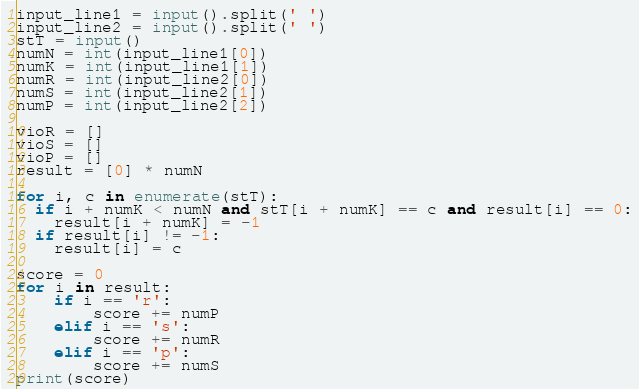Convert code to text. <code><loc_0><loc_0><loc_500><loc_500><_Python_>input_line1 = input().split(' ')
input_line2 = input().split(' ')
stT = input()
numN = int(input_line1[0])
numK = int(input_line1[1])
numR = int(input_line2[0])
numS = int(input_line2[1])
numP = int(input_line2[2])

vioR = []
vioS = []
vioP = []
result = [0] * numN 

for i, c in enumerate(stT):
  if i + numK < numN and stT[i + numK] == c and result[i] == 0:
    result[i + numK] = -1
  if result[i] != -1:
    result[i] = c

score = 0
for i in result:
    if i == 'r':
        score += numP
    elif i == 's':
        score += numR
    elif i == 'p':
        score += numS
print(score)</code> 